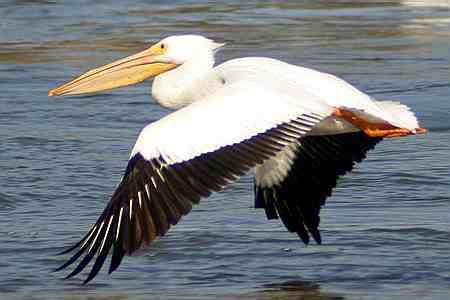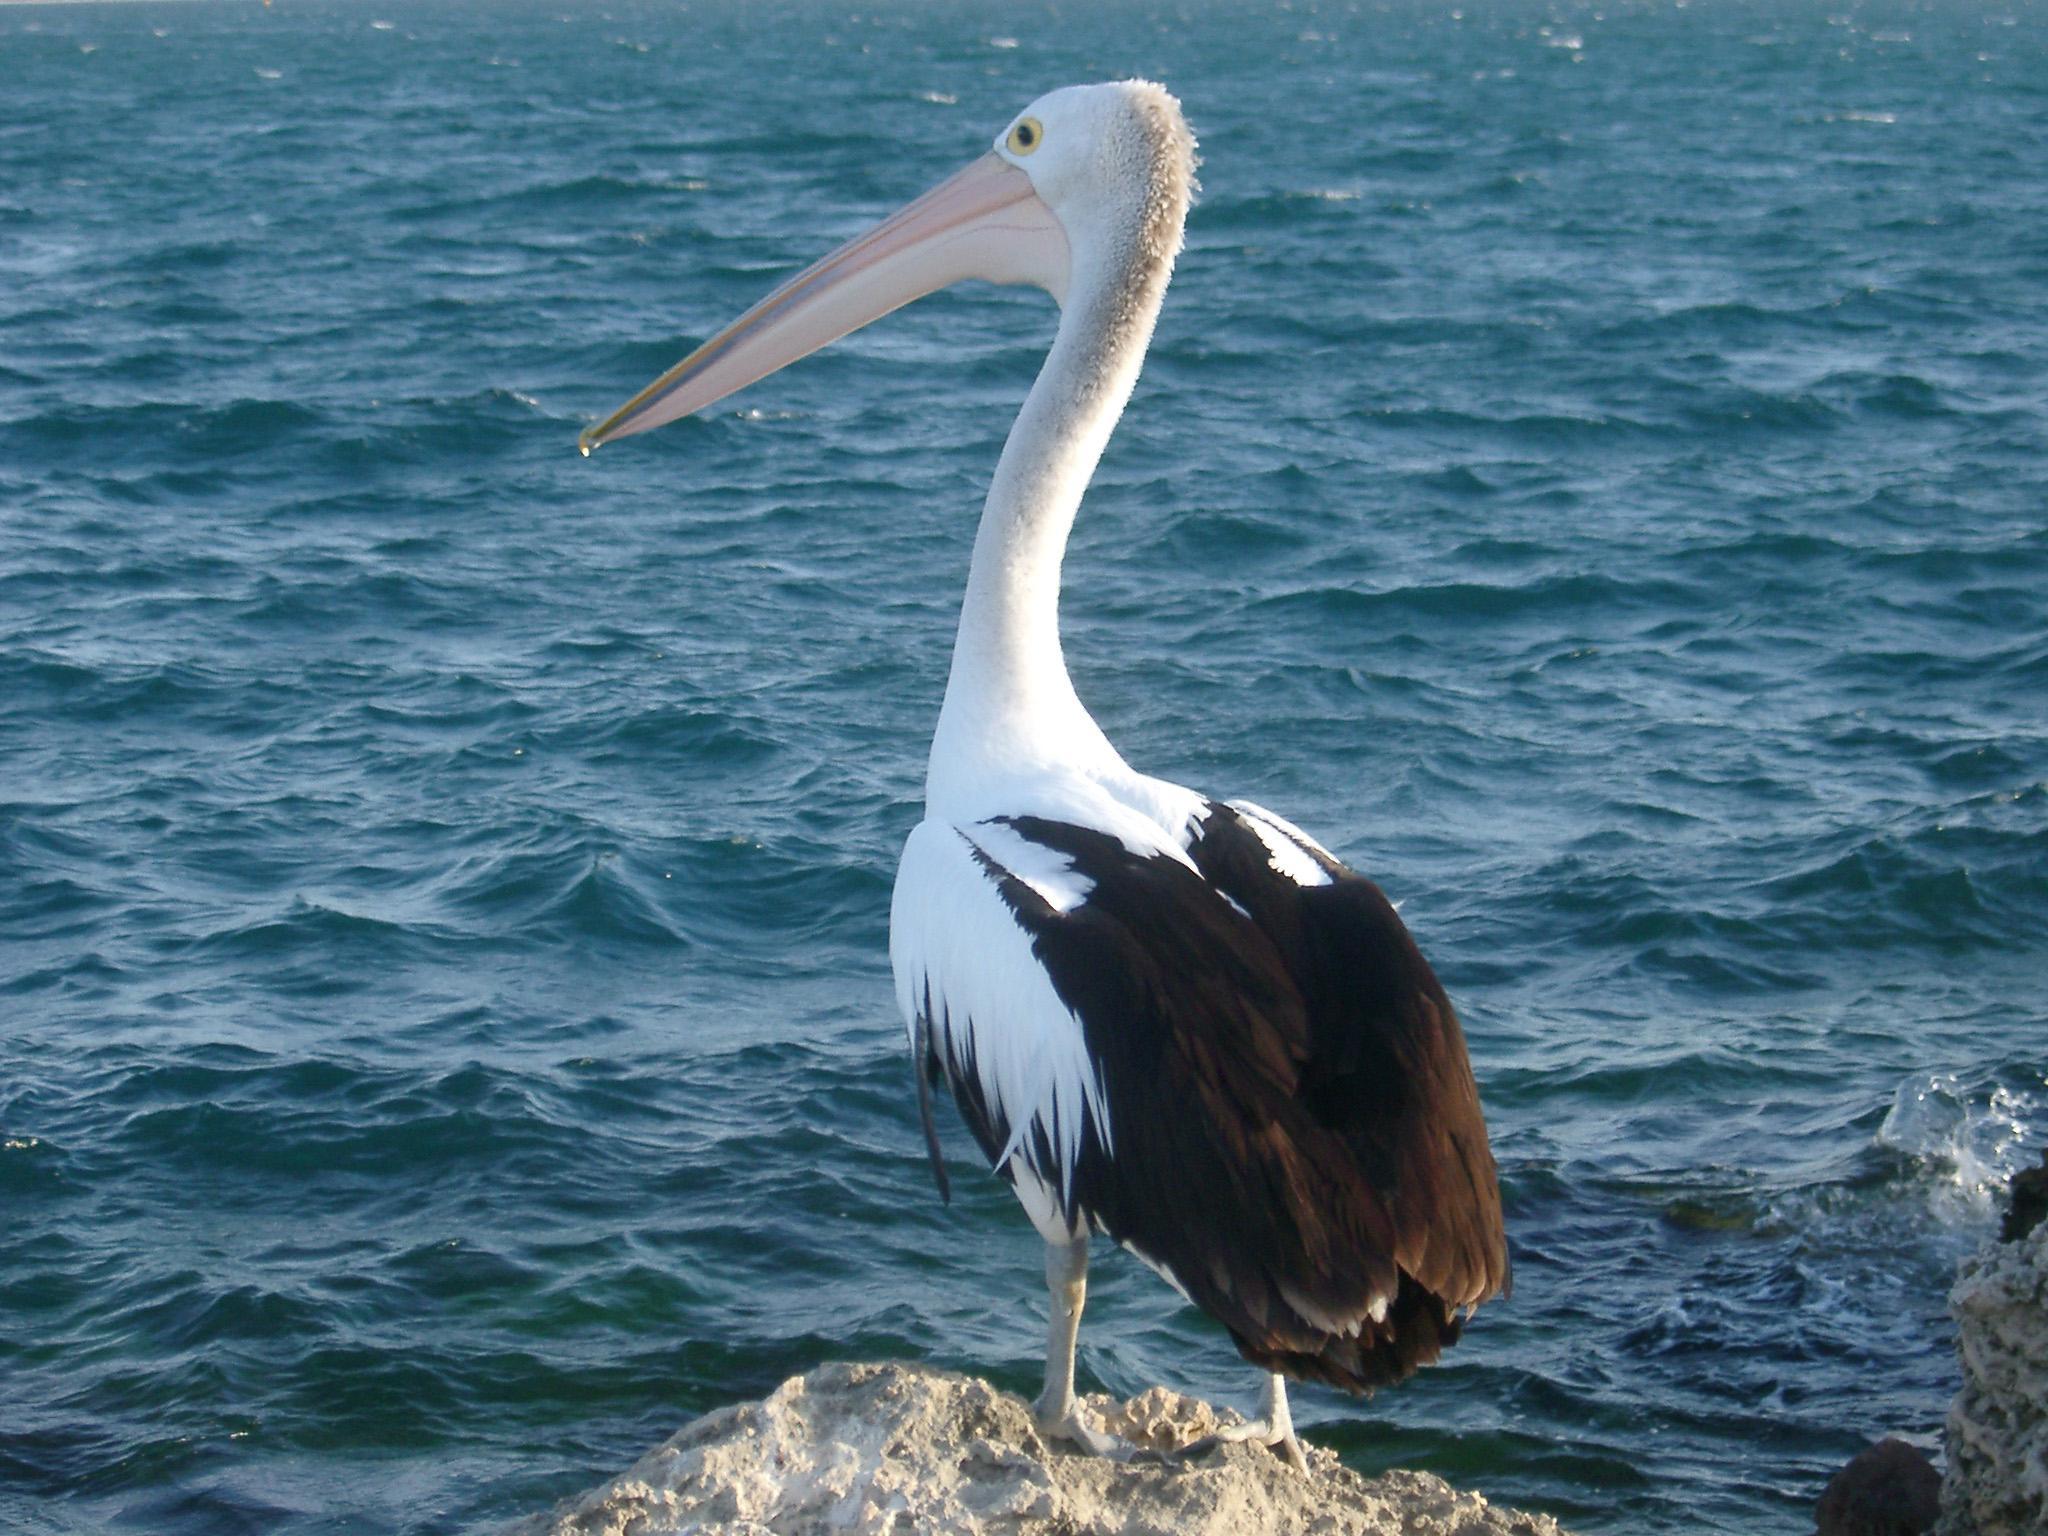The first image is the image on the left, the second image is the image on the right. Assess this claim about the two images: "At least one bird is sitting on water.". Correct or not? Answer yes or no. No. 